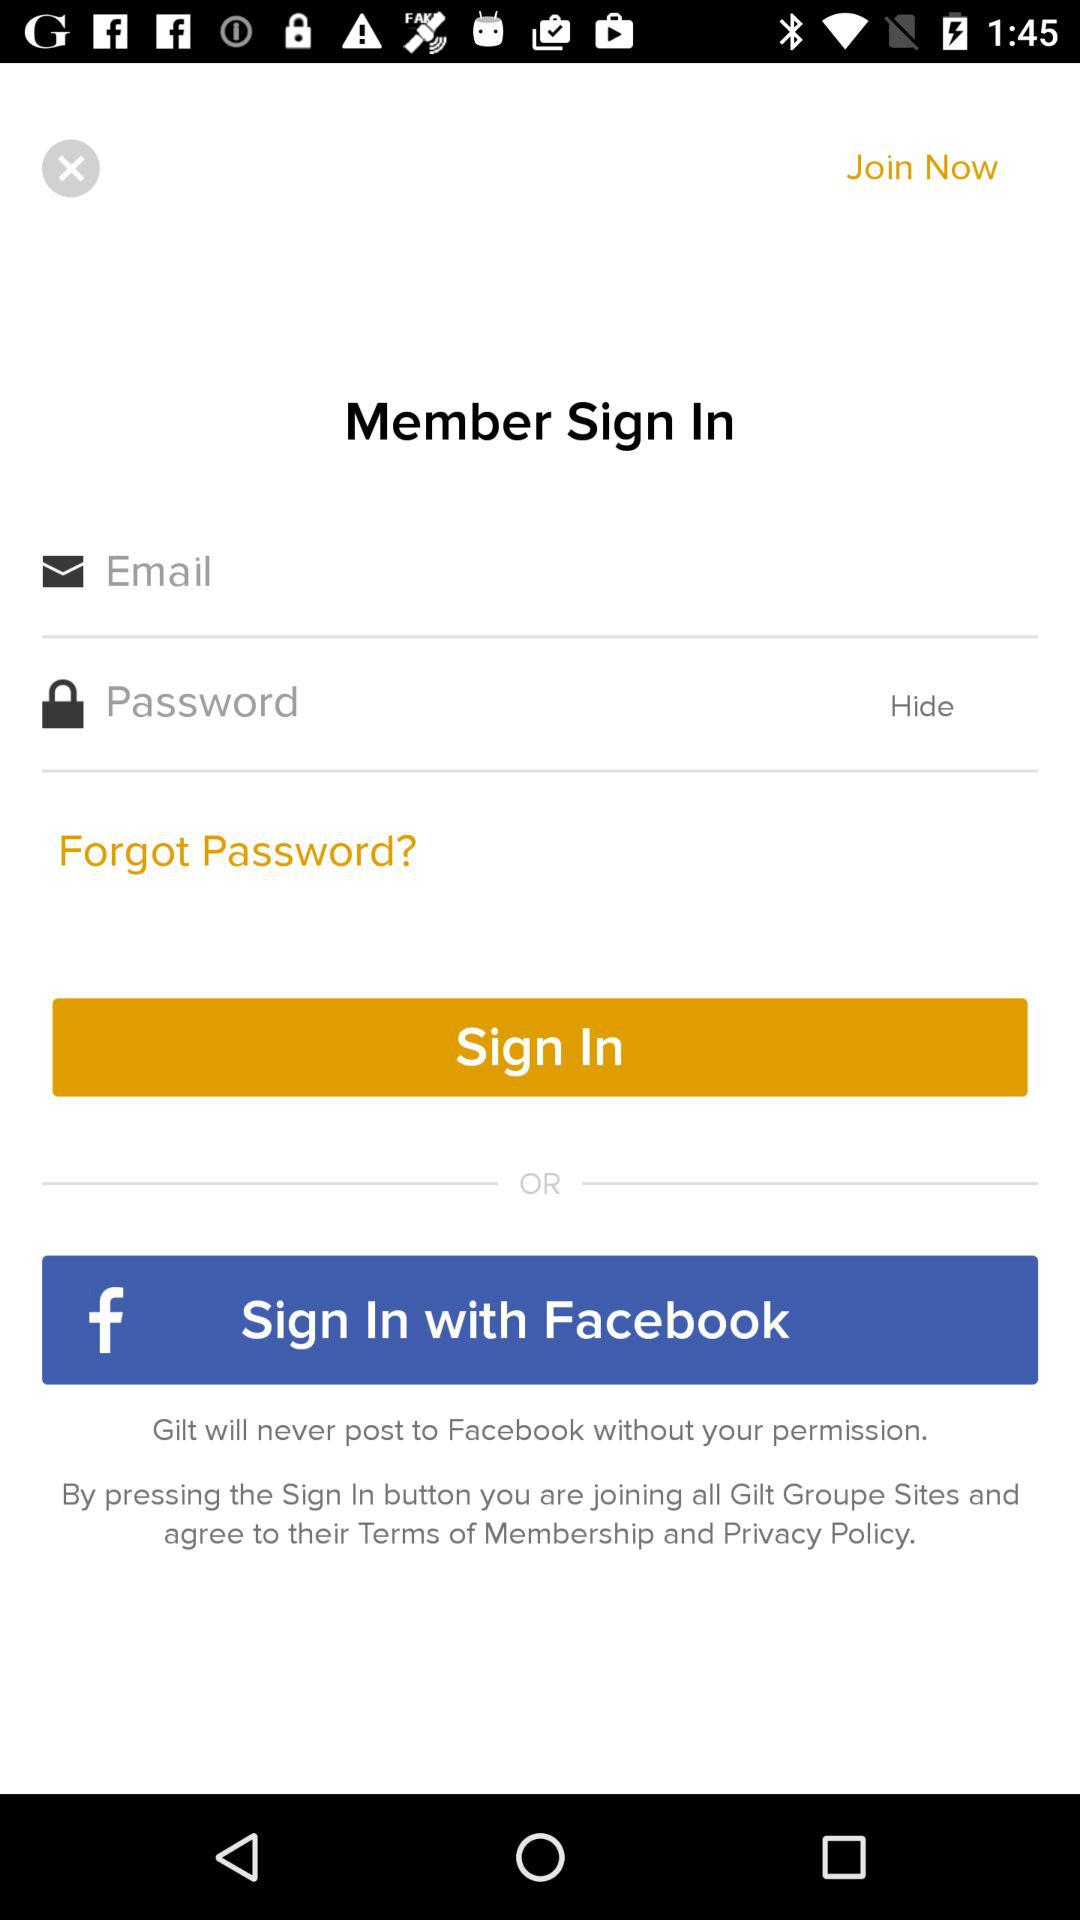What is the name of the application? The application name is "Gilt". 